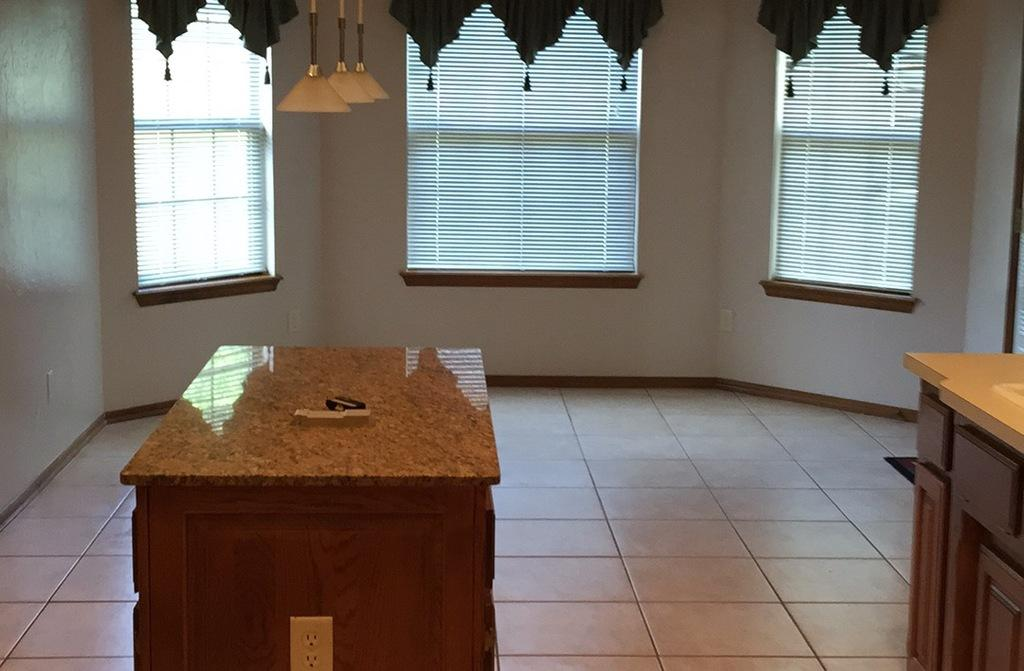What type of furniture can be seen in the image? There are tables in the image. What is visible beneath the tables? There is a floor visible in the image. What can be seen in the background of the image? There are windows, curtains, and a wall in the background of the image. What type of toad is sitting on the table in the image? There is no toad present in the image; only tables, a floor, and background elements are visible. 